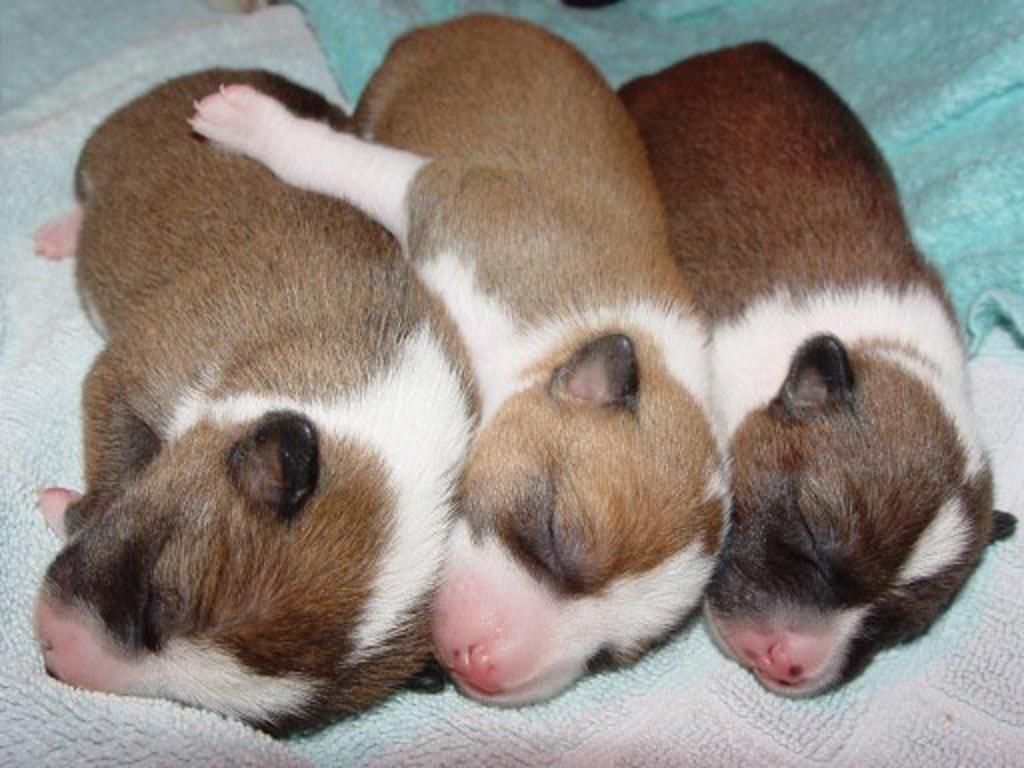How would you summarize this image in a sentence or two? In this image there are three dogs sleeping on the carpet. 